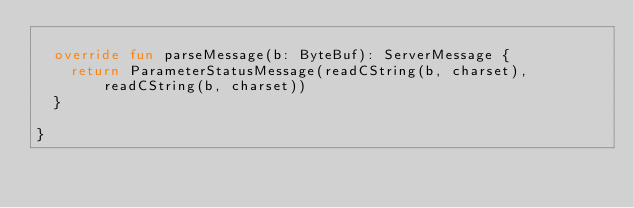Convert code to text. <code><loc_0><loc_0><loc_500><loc_500><_Kotlin_>
  override fun parseMessage(b: ByteBuf): ServerMessage {
    return ParameterStatusMessage(readCString(b, charset), readCString(b, charset))
  }

}
</code> 